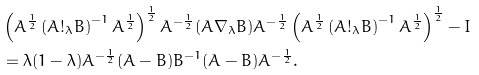<formula> <loc_0><loc_0><loc_500><loc_500>& \left ( A ^ { \frac { 1 } { 2 } } \left ( A ! _ { \lambda } B \right ) ^ { - 1 } A ^ { \frac { 1 } { 2 } } \right ) ^ { \frac { 1 } { 2 } } A ^ { - \frac { 1 } { 2 } } ( A \nabla _ { \lambda } B ) A ^ { - \frac { 1 } { 2 } } \left ( A ^ { \frac { 1 } { 2 } } \left ( A ! _ { \lambda } B \right ) ^ { - 1 } A ^ { \frac { 1 } { 2 } } \right ) ^ { \frac { 1 } { 2 } } - I \\ & = \lambda ( 1 - \lambda ) A ^ { - \frac { 1 } { 2 } } ( A - B ) B ^ { - 1 } ( A - B ) A ^ { - \frac { 1 } { 2 } } .</formula> 